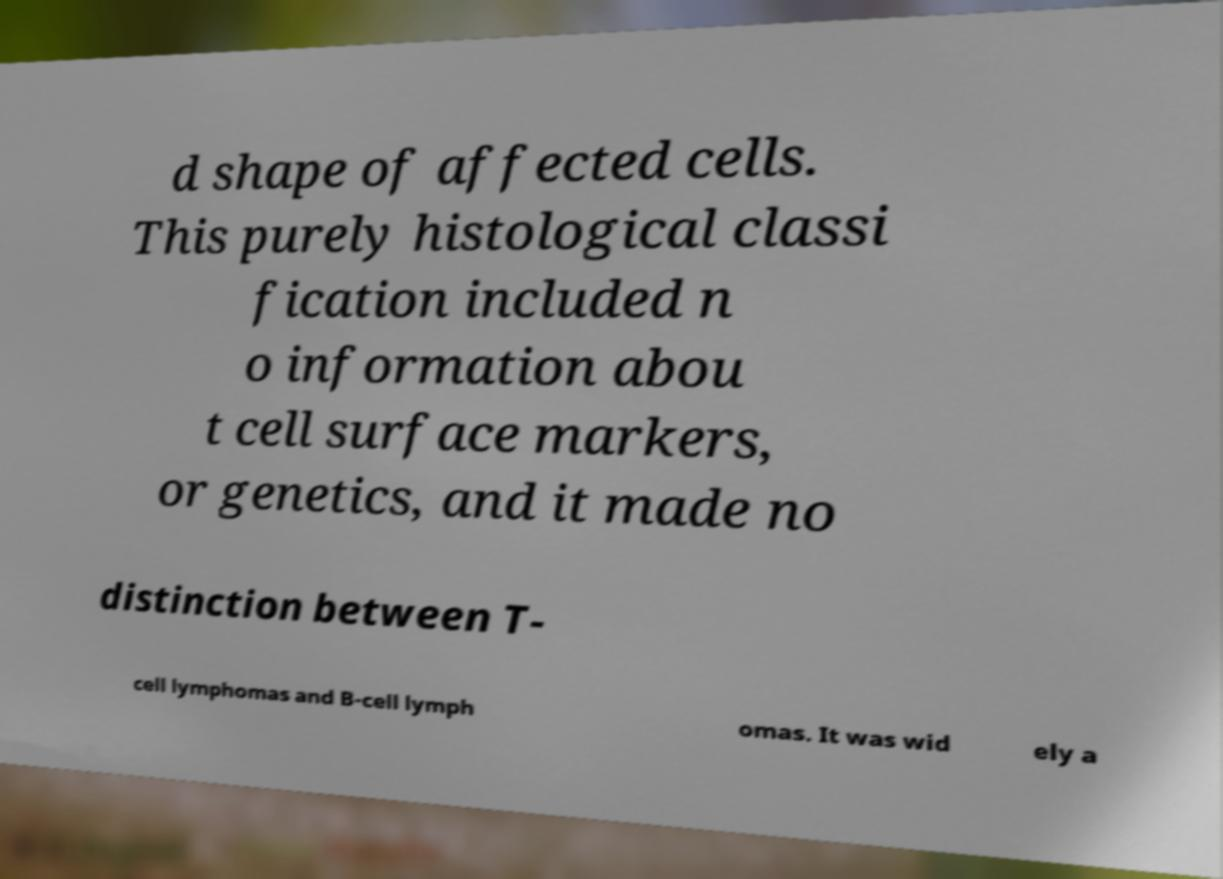Can you accurately transcribe the text from the provided image for me? d shape of affected cells. This purely histological classi fication included n o information abou t cell surface markers, or genetics, and it made no distinction between T- cell lymphomas and B-cell lymph omas. It was wid ely a 